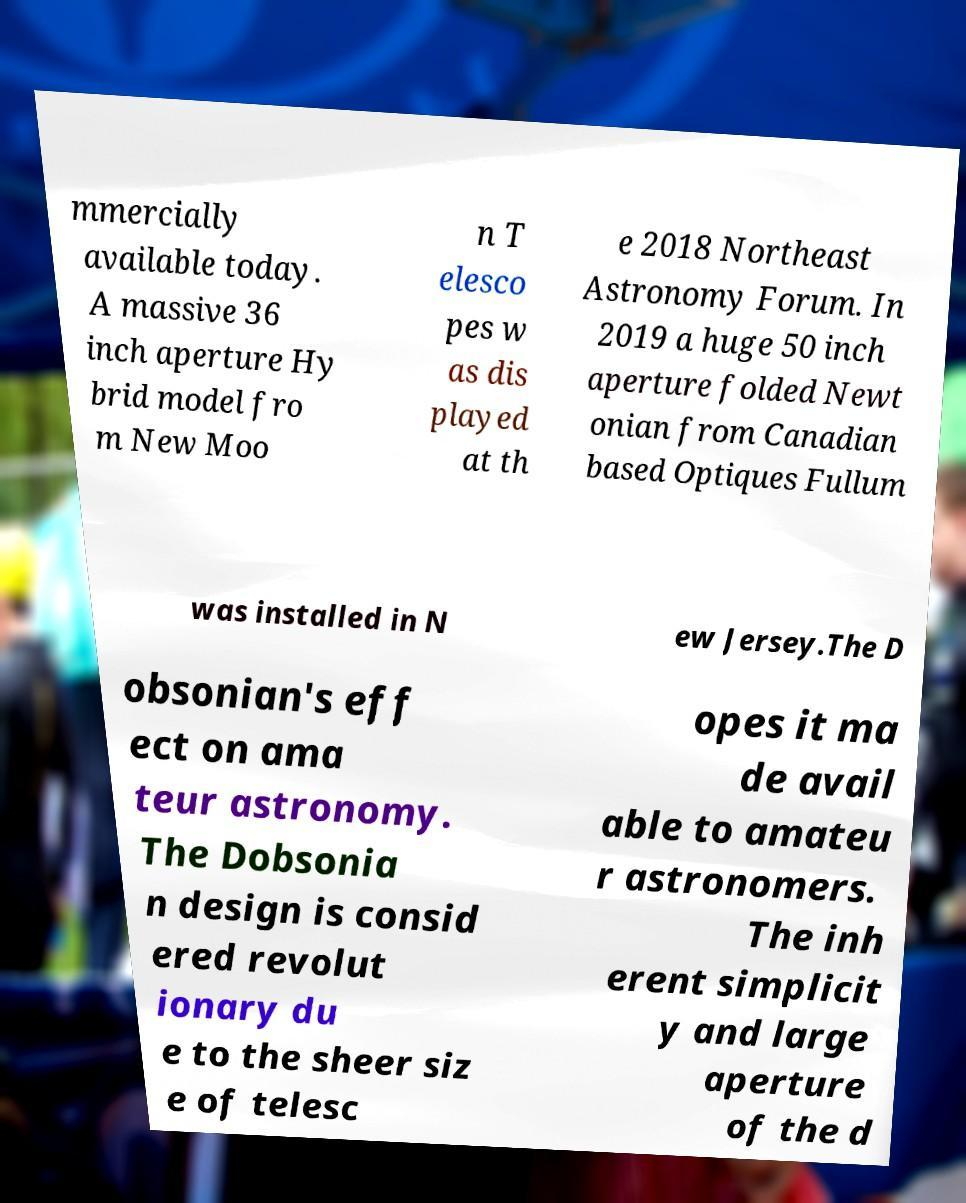What messages or text are displayed in this image? I need them in a readable, typed format. mmercially available today. A massive 36 inch aperture Hy brid model fro m New Moo n T elesco pes w as dis played at th e 2018 Northeast Astronomy Forum. In 2019 a huge 50 inch aperture folded Newt onian from Canadian based Optiques Fullum was installed in N ew Jersey.The D obsonian's eff ect on ama teur astronomy. The Dobsonia n design is consid ered revolut ionary du e to the sheer siz e of telesc opes it ma de avail able to amateu r astronomers. The inh erent simplicit y and large aperture of the d 